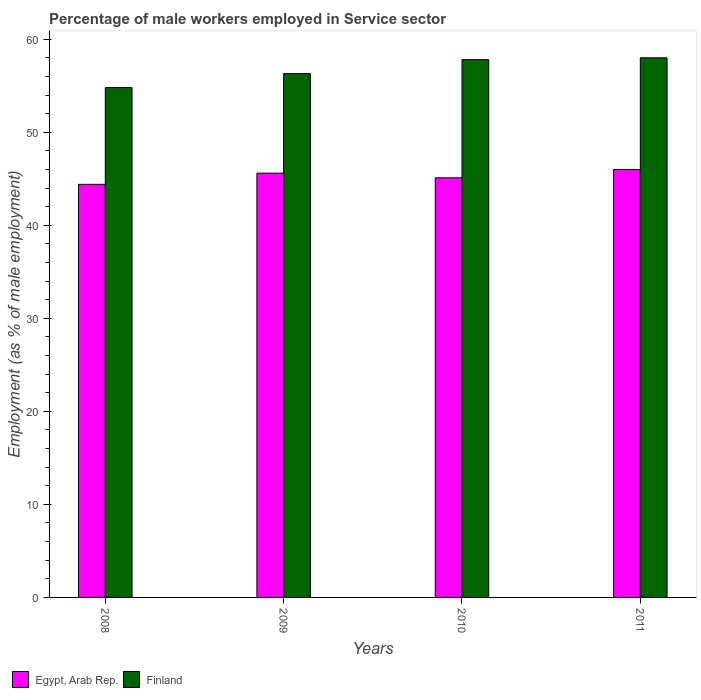How many different coloured bars are there?
Your response must be concise. 2. Are the number of bars per tick equal to the number of legend labels?
Offer a terse response. Yes. Are the number of bars on each tick of the X-axis equal?
Your answer should be compact. Yes. How many bars are there on the 3rd tick from the left?
Your answer should be very brief. 2. How many bars are there on the 1st tick from the right?
Offer a terse response. 2. What is the label of the 3rd group of bars from the left?
Offer a terse response. 2010. In how many cases, is the number of bars for a given year not equal to the number of legend labels?
Offer a terse response. 0. Across all years, what is the minimum percentage of male workers employed in Service sector in Finland?
Offer a terse response. 54.8. In which year was the percentage of male workers employed in Service sector in Finland maximum?
Your answer should be compact. 2011. In which year was the percentage of male workers employed in Service sector in Finland minimum?
Provide a short and direct response. 2008. What is the total percentage of male workers employed in Service sector in Finland in the graph?
Provide a succinct answer. 226.9. What is the difference between the percentage of male workers employed in Service sector in Finland in 2008 and that in 2009?
Keep it short and to the point. -1.5. What is the difference between the percentage of male workers employed in Service sector in Egypt, Arab Rep. in 2011 and the percentage of male workers employed in Service sector in Finland in 2009?
Offer a terse response. -10.3. What is the average percentage of male workers employed in Service sector in Finland per year?
Provide a short and direct response. 56.72. In the year 2008, what is the difference between the percentage of male workers employed in Service sector in Egypt, Arab Rep. and percentage of male workers employed in Service sector in Finland?
Provide a short and direct response. -10.4. In how many years, is the percentage of male workers employed in Service sector in Finland greater than 46 %?
Provide a succinct answer. 4. What is the ratio of the percentage of male workers employed in Service sector in Finland in 2008 to that in 2009?
Offer a very short reply. 0.97. What is the difference between the highest and the second highest percentage of male workers employed in Service sector in Egypt, Arab Rep.?
Keep it short and to the point. 0.4. What is the difference between the highest and the lowest percentage of male workers employed in Service sector in Finland?
Provide a short and direct response. 3.2. What does the 2nd bar from the left in 2009 represents?
Your answer should be compact. Finland. What does the 1st bar from the right in 2008 represents?
Offer a very short reply. Finland. How many bars are there?
Offer a terse response. 8. Are all the bars in the graph horizontal?
Offer a very short reply. No. Where does the legend appear in the graph?
Provide a short and direct response. Bottom left. What is the title of the graph?
Make the answer very short. Percentage of male workers employed in Service sector. What is the label or title of the Y-axis?
Make the answer very short. Employment (as % of male employment). What is the Employment (as % of male employment) in Egypt, Arab Rep. in 2008?
Make the answer very short. 44.4. What is the Employment (as % of male employment) of Finland in 2008?
Your response must be concise. 54.8. What is the Employment (as % of male employment) in Egypt, Arab Rep. in 2009?
Give a very brief answer. 45.6. What is the Employment (as % of male employment) in Finland in 2009?
Keep it short and to the point. 56.3. What is the Employment (as % of male employment) of Egypt, Arab Rep. in 2010?
Offer a very short reply. 45.1. What is the Employment (as % of male employment) in Finland in 2010?
Your answer should be very brief. 57.8. What is the Employment (as % of male employment) of Egypt, Arab Rep. in 2011?
Offer a very short reply. 46. What is the Employment (as % of male employment) in Finland in 2011?
Keep it short and to the point. 58. Across all years, what is the maximum Employment (as % of male employment) in Egypt, Arab Rep.?
Provide a succinct answer. 46. Across all years, what is the maximum Employment (as % of male employment) in Finland?
Keep it short and to the point. 58. Across all years, what is the minimum Employment (as % of male employment) in Egypt, Arab Rep.?
Give a very brief answer. 44.4. Across all years, what is the minimum Employment (as % of male employment) of Finland?
Ensure brevity in your answer.  54.8. What is the total Employment (as % of male employment) in Egypt, Arab Rep. in the graph?
Give a very brief answer. 181.1. What is the total Employment (as % of male employment) in Finland in the graph?
Provide a succinct answer. 226.9. What is the difference between the Employment (as % of male employment) of Egypt, Arab Rep. in 2008 and that in 2010?
Offer a terse response. -0.7. What is the difference between the Employment (as % of male employment) in Egypt, Arab Rep. in 2009 and that in 2010?
Offer a very short reply. 0.5. What is the difference between the Employment (as % of male employment) in Finland in 2009 and that in 2010?
Offer a very short reply. -1.5. What is the difference between the Employment (as % of male employment) of Egypt, Arab Rep. in 2009 and that in 2011?
Your response must be concise. -0.4. What is the difference between the Employment (as % of male employment) in Finland in 2010 and that in 2011?
Provide a short and direct response. -0.2. What is the difference between the Employment (as % of male employment) of Egypt, Arab Rep. in 2008 and the Employment (as % of male employment) of Finland in 2009?
Provide a succinct answer. -11.9. What is the difference between the Employment (as % of male employment) in Egypt, Arab Rep. in 2009 and the Employment (as % of male employment) in Finland in 2010?
Offer a terse response. -12.2. What is the difference between the Employment (as % of male employment) in Egypt, Arab Rep. in 2010 and the Employment (as % of male employment) in Finland in 2011?
Your answer should be compact. -12.9. What is the average Employment (as % of male employment) in Egypt, Arab Rep. per year?
Offer a terse response. 45.27. What is the average Employment (as % of male employment) in Finland per year?
Your answer should be compact. 56.73. In the year 2011, what is the difference between the Employment (as % of male employment) in Egypt, Arab Rep. and Employment (as % of male employment) in Finland?
Ensure brevity in your answer.  -12. What is the ratio of the Employment (as % of male employment) in Egypt, Arab Rep. in 2008 to that in 2009?
Your response must be concise. 0.97. What is the ratio of the Employment (as % of male employment) in Finland in 2008 to that in 2009?
Your answer should be compact. 0.97. What is the ratio of the Employment (as % of male employment) of Egypt, Arab Rep. in 2008 to that in 2010?
Your response must be concise. 0.98. What is the ratio of the Employment (as % of male employment) in Finland in 2008 to that in 2010?
Provide a succinct answer. 0.95. What is the ratio of the Employment (as % of male employment) in Egypt, Arab Rep. in 2008 to that in 2011?
Provide a succinct answer. 0.97. What is the ratio of the Employment (as % of male employment) of Finland in 2008 to that in 2011?
Offer a very short reply. 0.94. What is the ratio of the Employment (as % of male employment) of Egypt, Arab Rep. in 2009 to that in 2010?
Your answer should be very brief. 1.01. What is the ratio of the Employment (as % of male employment) of Finland in 2009 to that in 2011?
Your response must be concise. 0.97. What is the ratio of the Employment (as % of male employment) in Egypt, Arab Rep. in 2010 to that in 2011?
Your answer should be compact. 0.98. What is the ratio of the Employment (as % of male employment) in Finland in 2010 to that in 2011?
Keep it short and to the point. 1. What is the difference between the highest and the second highest Employment (as % of male employment) of Egypt, Arab Rep.?
Your answer should be compact. 0.4. What is the difference between the highest and the lowest Employment (as % of male employment) of Finland?
Offer a very short reply. 3.2. 